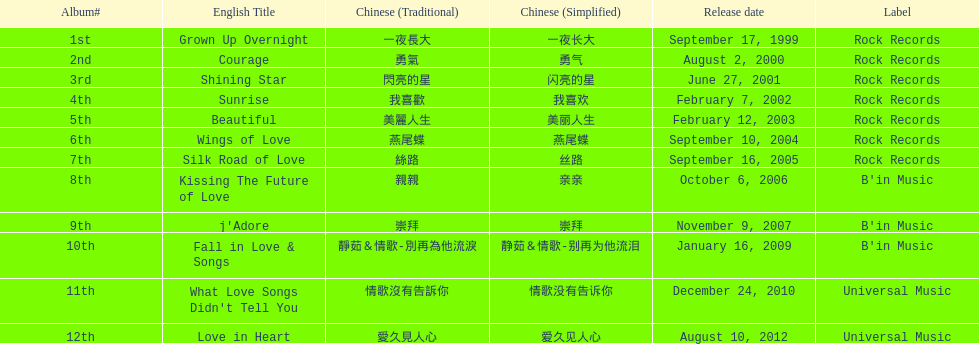Did the album beautiful come out before the album love in heart? Yes. 